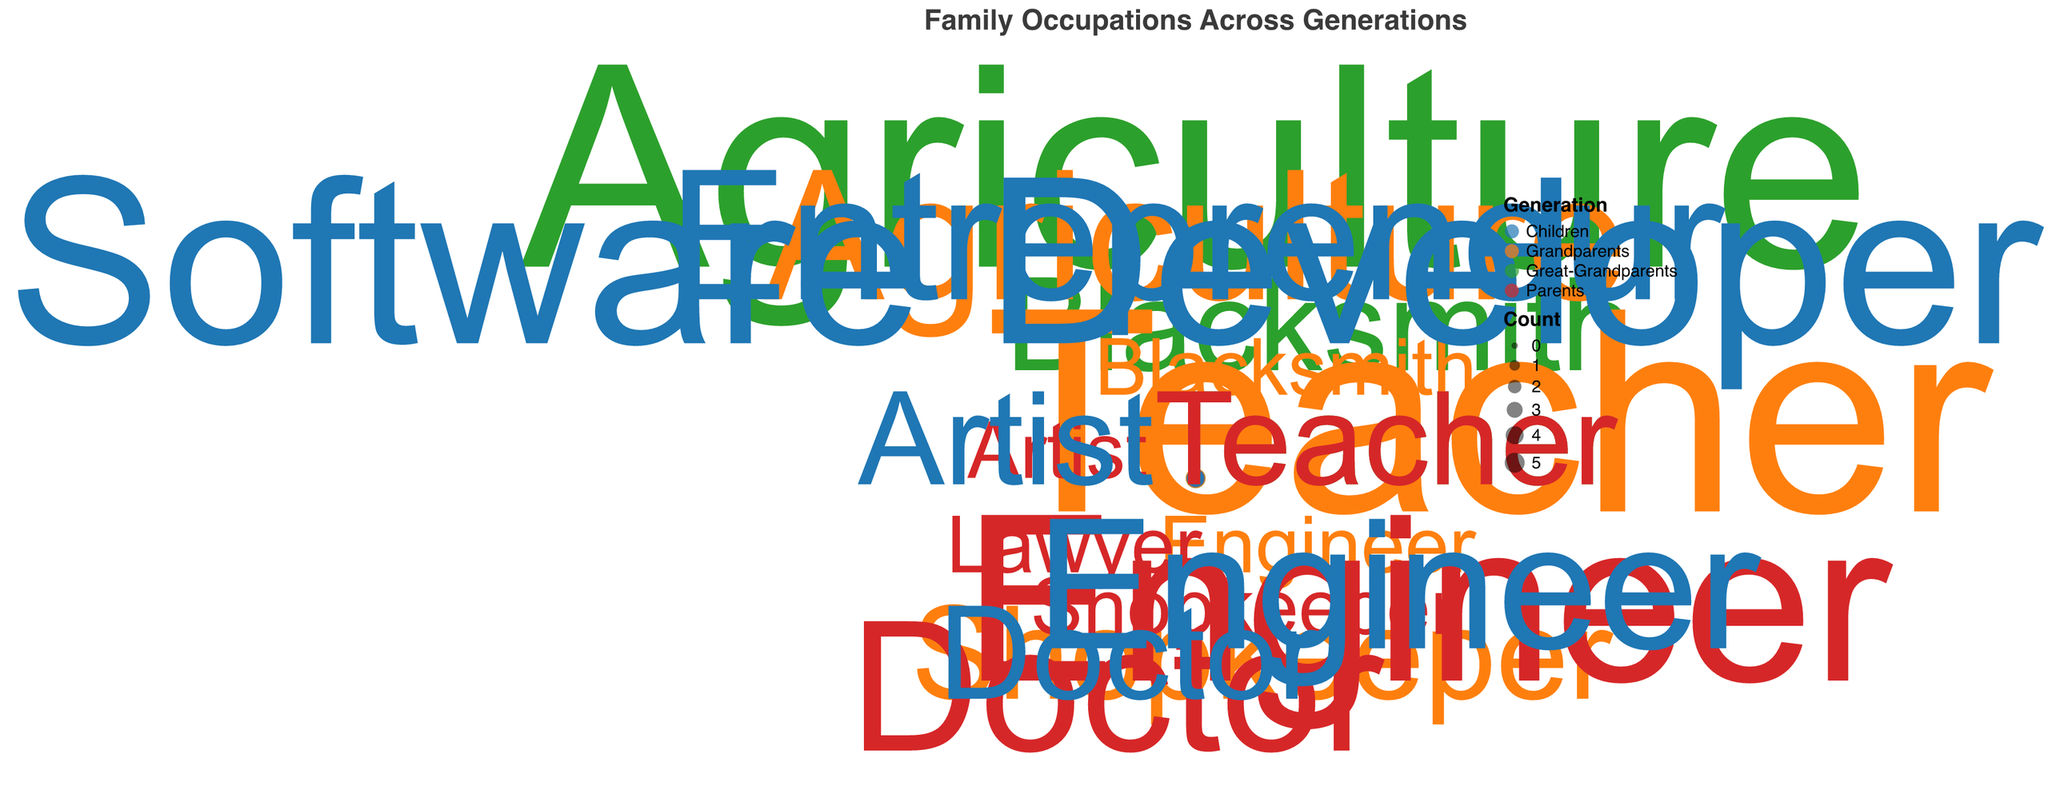How many generations are represented in the plot? There are four distinct generations represented in the plot: "Great-Grandparents", "Grandparents", "Parents", and "Children".
Answer: 4 Which occupation has the highest count in the "Great-Grandparents" generation? By looking at the size and number of points in the "Great-Grandparents" generation, "Agriculture" has the highest count with 5.
Answer: Agriculture What is the difference in count for the "Teacher" occupation between "Grandparents" and "Parents"? The count for the "Teacher" occupation among "Grandparents" is 5, and among "Parents" it is 2. The difference is 5 - 2.
Answer: 3 Which generation has the highest diversity in occupations? The "Parents" generation shows the highest diversity with six different occupations: Teacher, Engineer, Doctor, Lawyer, Shopkeeper, and Artist.
Answer: Parents How does the count of "Engineer" occupations change from "Grandparents" to "Children"? The count of "Engineer" occupations is 1 among "Grandparents", 4 among "Parents", and 3 among "Children". The count increased from "Grandparents" to "Parents" but decreased from "Parents" to "Children".
Answer: Increased then decreased Which generation has the lowest presence in "Shopkeeper" occupation? The "Parents" generation has the lowest presence in the "Shopkeeper" occupation with a count of 1, while the "Grandparents" generation has 2.
Answer: Parents Is there any occupation that appears only in the "Children" generation? Yes, "Software Developer" and "Entrepreneur" appear only in the "Children" generation.
Answer: Yes What change can be observed in the count of "Agriculture" occupation over generations? The count of the "Agriculture" occupation starts at 5 in "Great-Grandparents", decreases to 3 in "Grandparents", and then drops to 0 in "Parents" and "Children".
Answer: Decreases to 0 What occupation has consistently appeared across all four generations? "Teacher" is the only occupation that consistently appears across all four generations: Great-Grandparents, Grandparents, Parents, and Children.
Answer: Teacher 